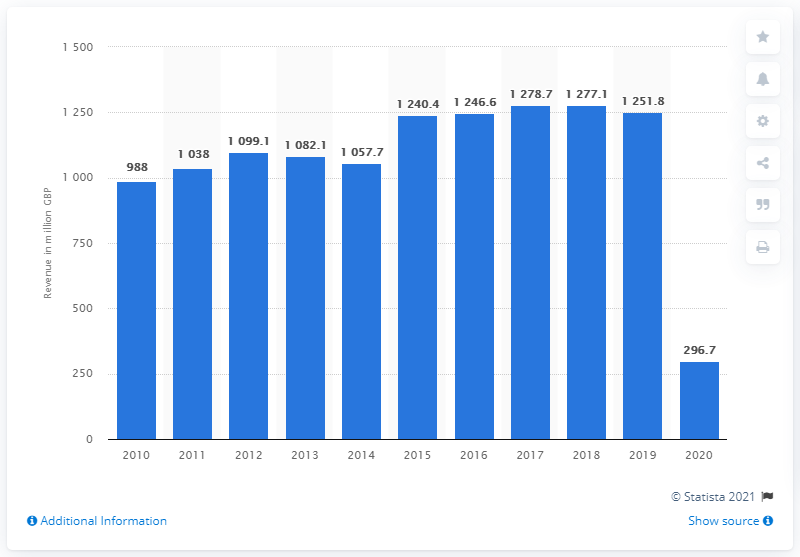Highlight a few significant elements in this photo. In the United Kingdom in 2019, the box office revenue was £1251.8 million. The COVID-19 pandemic, which led to the closure of movie theaters, caused a decline in the box office revenue of $296.7 million. 